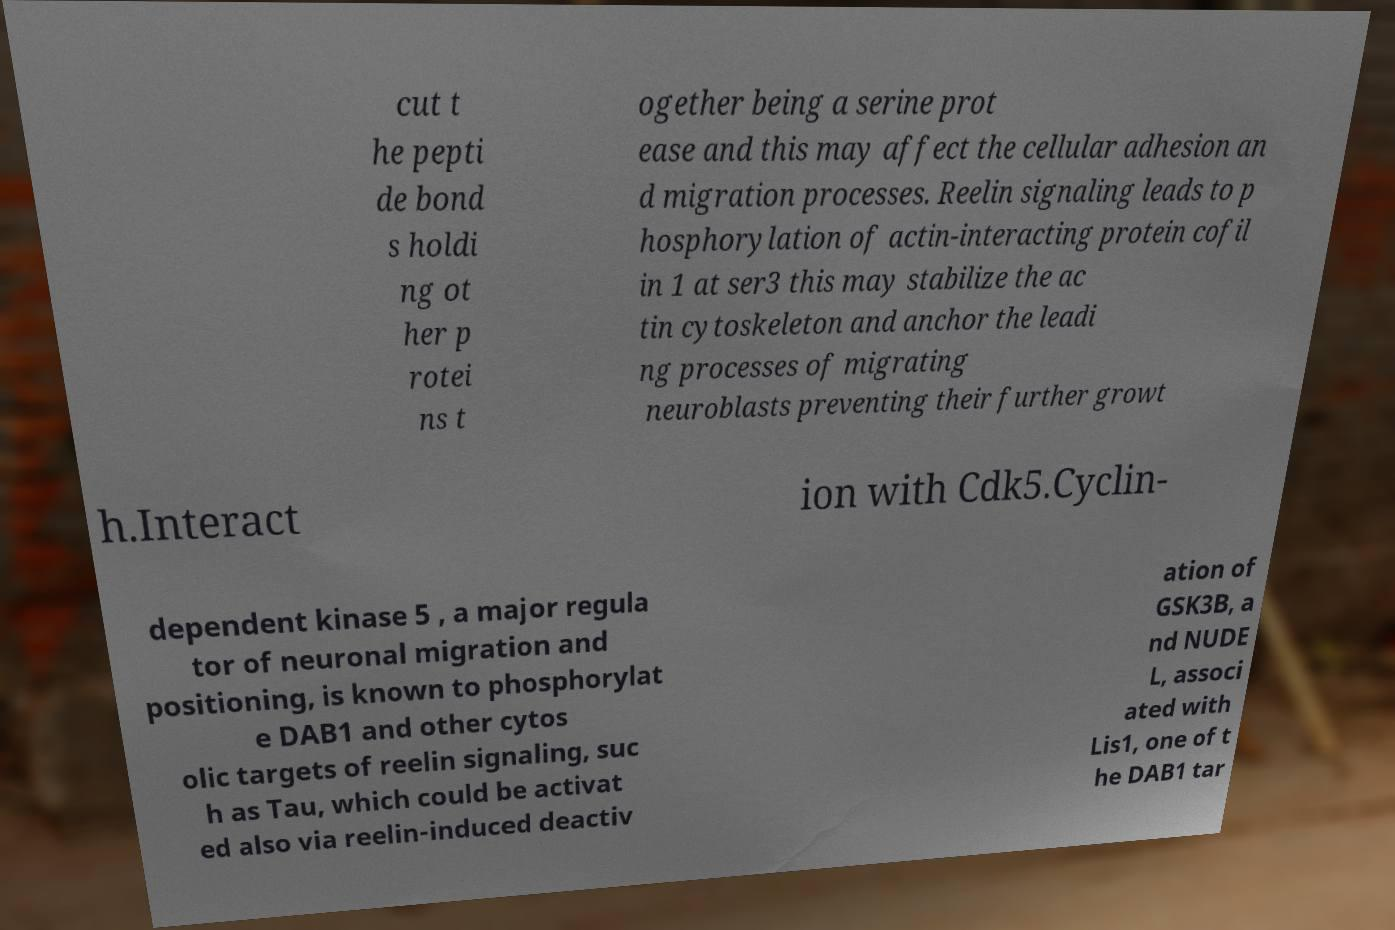Could you assist in decoding the text presented in this image and type it out clearly? cut t he pepti de bond s holdi ng ot her p rotei ns t ogether being a serine prot ease and this may affect the cellular adhesion an d migration processes. Reelin signaling leads to p hosphorylation of actin-interacting protein cofil in 1 at ser3 this may stabilize the ac tin cytoskeleton and anchor the leadi ng processes of migrating neuroblasts preventing their further growt h.Interact ion with Cdk5.Cyclin- dependent kinase 5 , a major regula tor of neuronal migration and positioning, is known to phosphorylat e DAB1 and other cytos olic targets of reelin signaling, suc h as Tau, which could be activat ed also via reelin-induced deactiv ation of GSK3B, a nd NUDE L, associ ated with Lis1, one of t he DAB1 tar 